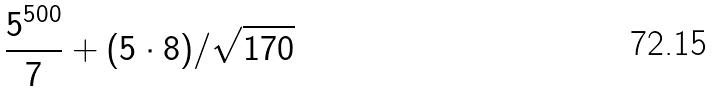<formula> <loc_0><loc_0><loc_500><loc_500>\frac { 5 ^ { 5 0 0 } } { 7 } + ( 5 \cdot 8 ) / \sqrt { 1 7 0 }</formula> 